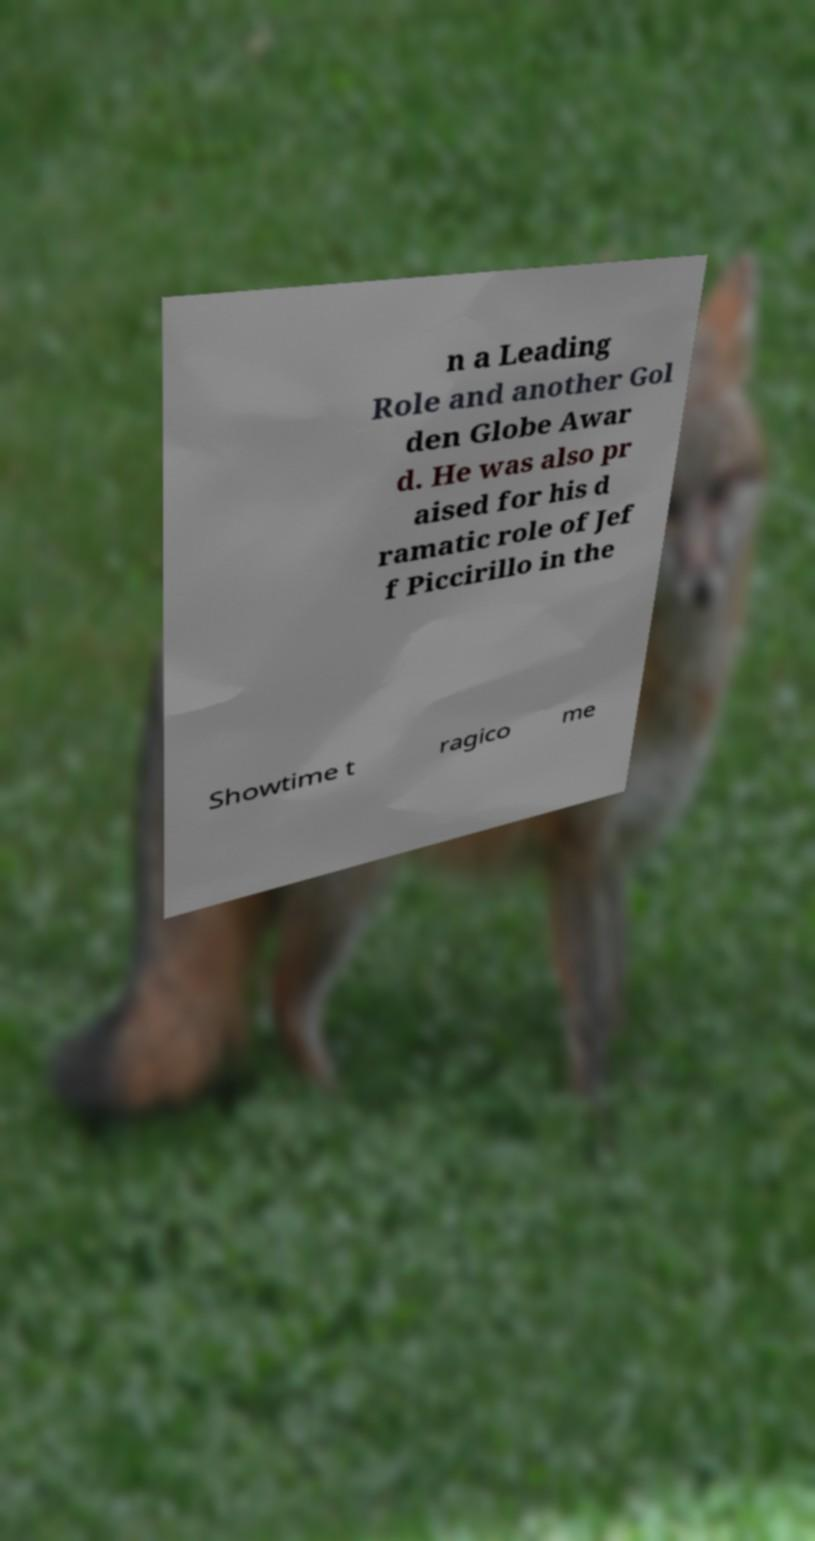Could you extract and type out the text from this image? n a Leading Role and another Gol den Globe Awar d. He was also pr aised for his d ramatic role of Jef f Piccirillo in the Showtime t ragico me 